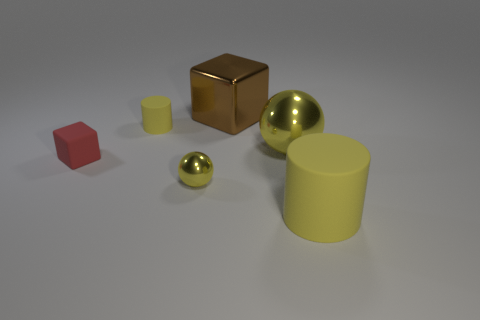Are there more metal objects in front of the big brown metal cube than small red blocks?
Your response must be concise. Yes. What is the shape of the large metallic object that is the same color as the tiny metallic object?
Provide a short and direct response. Sphere. How many blocks are yellow things or brown things?
Offer a terse response. 1. What is the color of the cylinder behind the big yellow object that is in front of the tiny matte block?
Provide a succinct answer. Yellow. There is a big matte thing; is it the same color as the rubber block on the left side of the big metal cube?
Offer a very short reply. No. The other cylinder that is made of the same material as the large cylinder is what size?
Provide a short and direct response. Small. What size is the other ball that is the same color as the tiny sphere?
Your response must be concise. Large. Is the tiny metallic ball the same color as the large cube?
Give a very brief answer. No. There is a sphere that is behind the ball that is to the left of the big brown shiny cube; is there a yellow rubber cylinder to the left of it?
Give a very brief answer. Yes. What number of balls have the same size as the metal block?
Offer a very short reply. 1. 